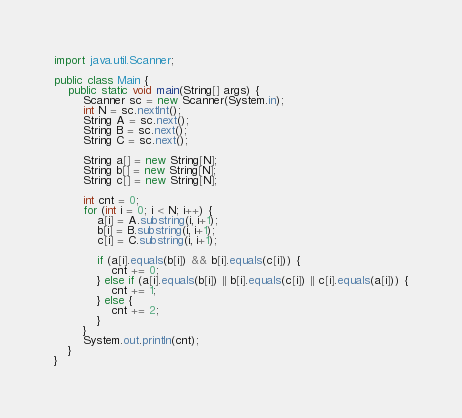<code> <loc_0><loc_0><loc_500><loc_500><_Java_>import java.util.Scanner;

public class Main {
	public static void main(String[] args) {
		Scanner sc = new Scanner(System.in);
		int N = sc.nextInt();
		String A = sc.next();
		String B = sc.next();
		String C = sc.next();

		String a[] = new String[N];
		String b[] = new String[N];
		String c[] = new String[N];

		int cnt = 0;
		for (int i = 0; i < N; i++) {
			a[i] = A.substring(i, i+1);
			b[i] = B.substring(i, i+1);
			c[i] = C.substring(i, i+1);

			if (a[i].equals(b[i]) && b[i].equals(c[i])) {
				cnt += 0;
			} else if (a[i].equals(b[i]) || b[i].equals(c[i]) || c[i].equals(a[i])) {
				cnt += 1;
			} else {
				cnt += 2;
			}
		}
		System.out.println(cnt);
	}
}
</code> 